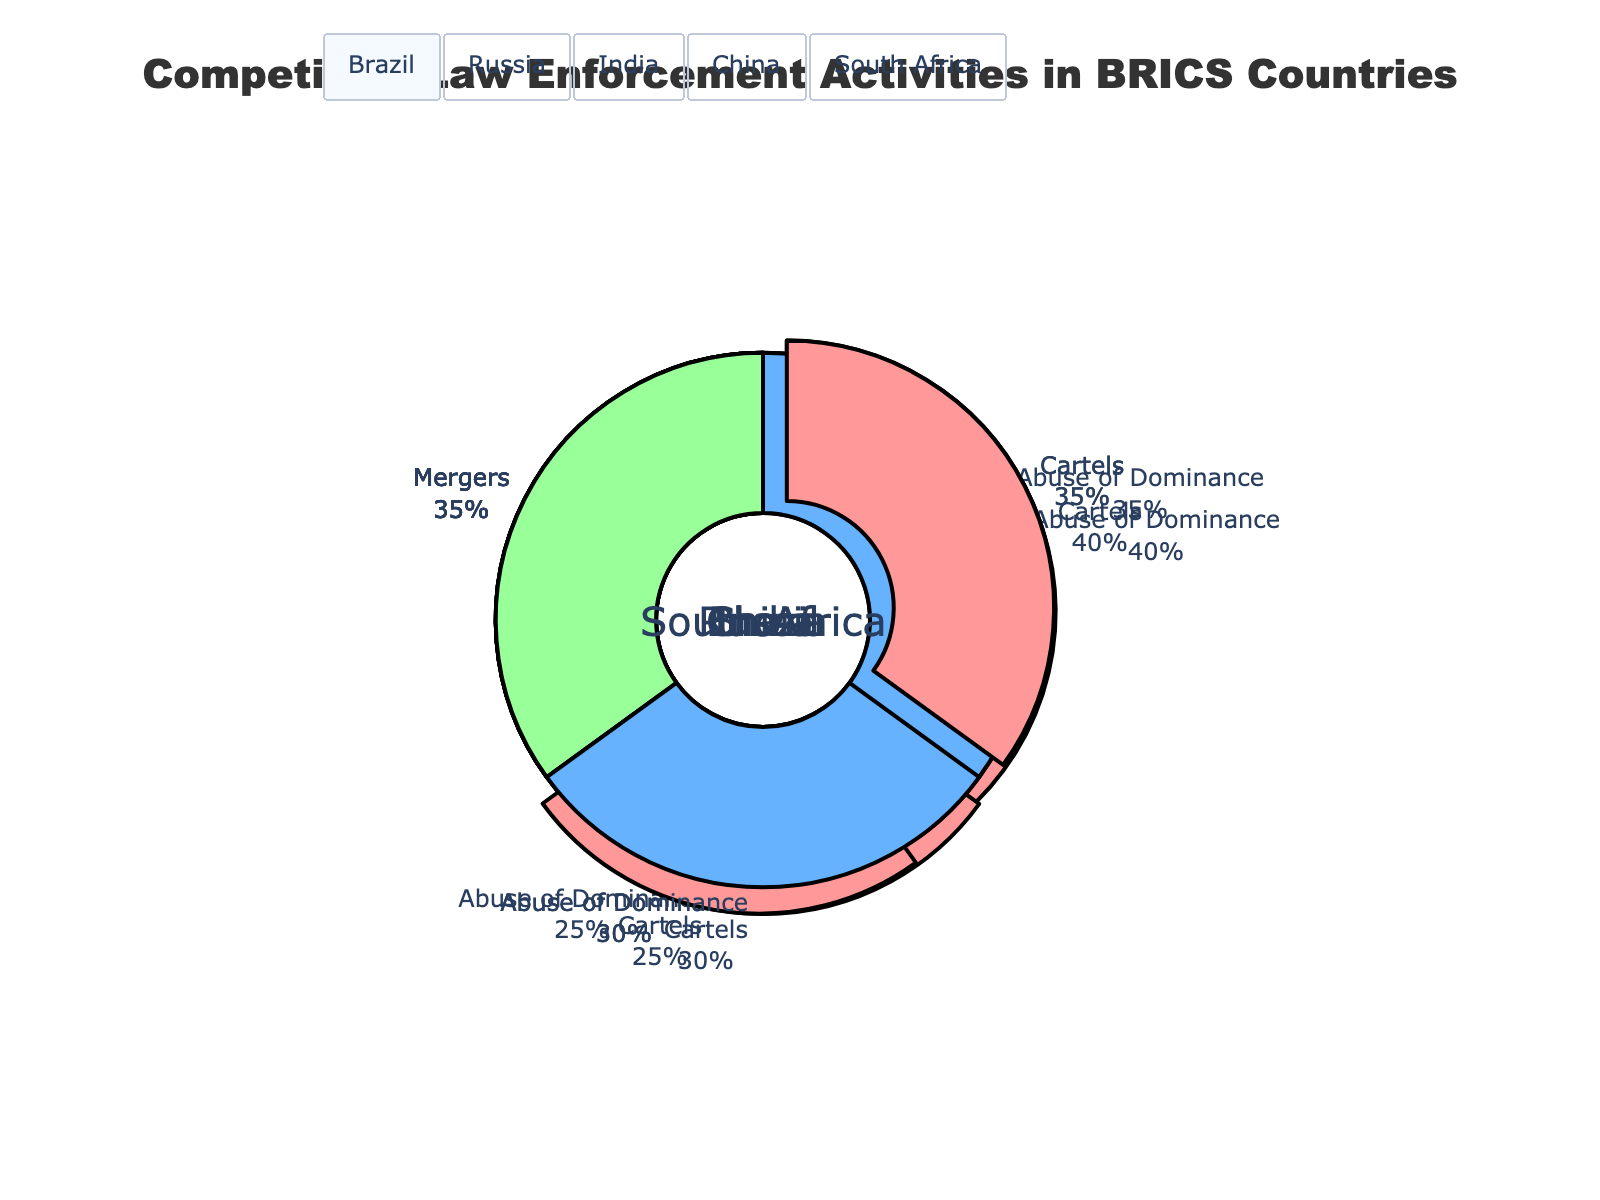Which BRICS country has the highest percentage of activities related to 'Abuse of Dominance'? By examining the pie charts, we can see that China has the highest percentage for 'Abuse of Dominance' at 40%.
Answer: China Which two BRICS countries have an equal percentage breakdown for 'Cartels' and 'Mergers'? By comparing the pie charts, we find that Brazil and South Africa both have 35% for 'Cartels' and 35% for 'Mergers'.
Answer: Brazil and South Africa In which country do 'Mergers' make up less activity than 'Cartels' and 'Abuse of Dominance'? Observing the pie charts, none of the countries have a lower percentage for 'Mergers' compared to both 'Cartels' and 'Abuse of Dominance'.
Answer: None What is the combined percentage of 'Cartels' and 'Abuse of Dominance' in Russia? In Russia, the 'Cartels' percentage is 40% and 'Abuse of Dominance' is 25%. Adding these values: 40% + 25% = 65%.
Answer: 65% Which BRICS country has the most balanced distribution among the three types of enforcement activities? Observing the pie charts, Brazil and South Africa have the most balanced distribution with percentages of 35%, 30%, and 35%.
Answer: Brazil and South Africa How much greater is the percentage of 'Abuse of Dominance' activities in China compared to Brazil? The percentage for 'Abuse of Dominance' in China is 40% and in Brazil, it is 30%. Therefore, 40% - 30% = 10%.
Answer: 10% Which type of enforcement activity is the least common in India? By examining India's pie chart, we see that the least common type of enforcement activity is 'Cartels' at 30%.
Answer: Cartels If you add the percentages for 'Cartels' across all BRICS countries, what is the sum? Adding the 'Cartels' percentages for Brazil (35%), Russia (40%), India (30%), China (25%), and South Africa (35%): 35% + 40% + 30% + 25% + 35% = 165%.
Answer: 165% Which BRICS country has the lowest percentage for 'Mergers'? All BRICS countries (Brazil, Russia, India, China, and South Africa) have an equal percentage for 'Mergers' at 35%.
Answer: All equal at 35% What is the average percentage for 'Abuse of Dominance' activities across all BRICS countries? Summing the percentages for 'Abuse of Dominance': 30% (Brazil) + 25% (Russia) + 35% (India) + 40% (China) + 30% (South Africa) = 160%. Dividing by 5 countries: 160% / 5 = 32%.
Answer: 32% 